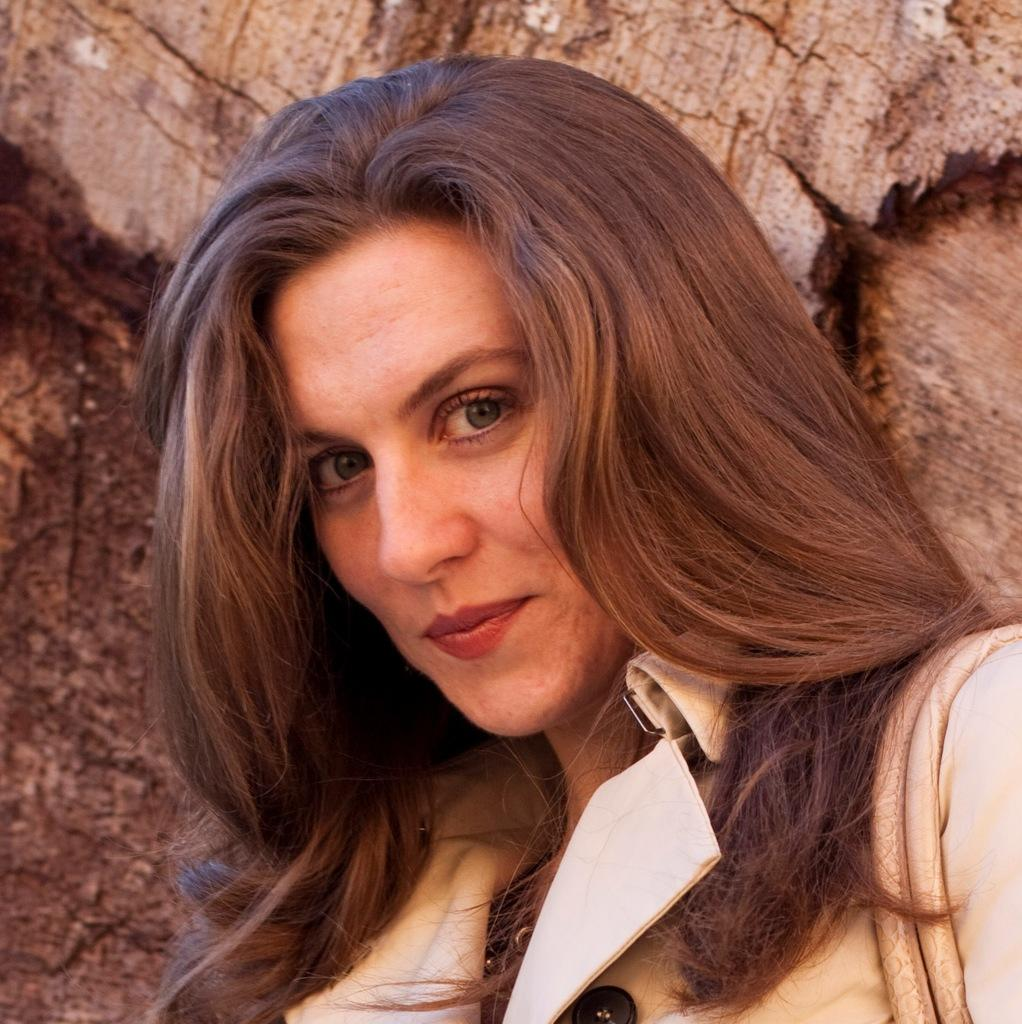Who is the main subject in the image? There is a woman in the image. What is the woman wearing? The woman is wearing a cream-colored dress. What accessory is the woman carrying? The woman is carrying a handbag. What can be seen in the background of the image? There is a brown-colored rock in the background of the image. What type of twig is the woman holding in the image? There is no twig present in the image; the woman is carrying a handbag instead. 